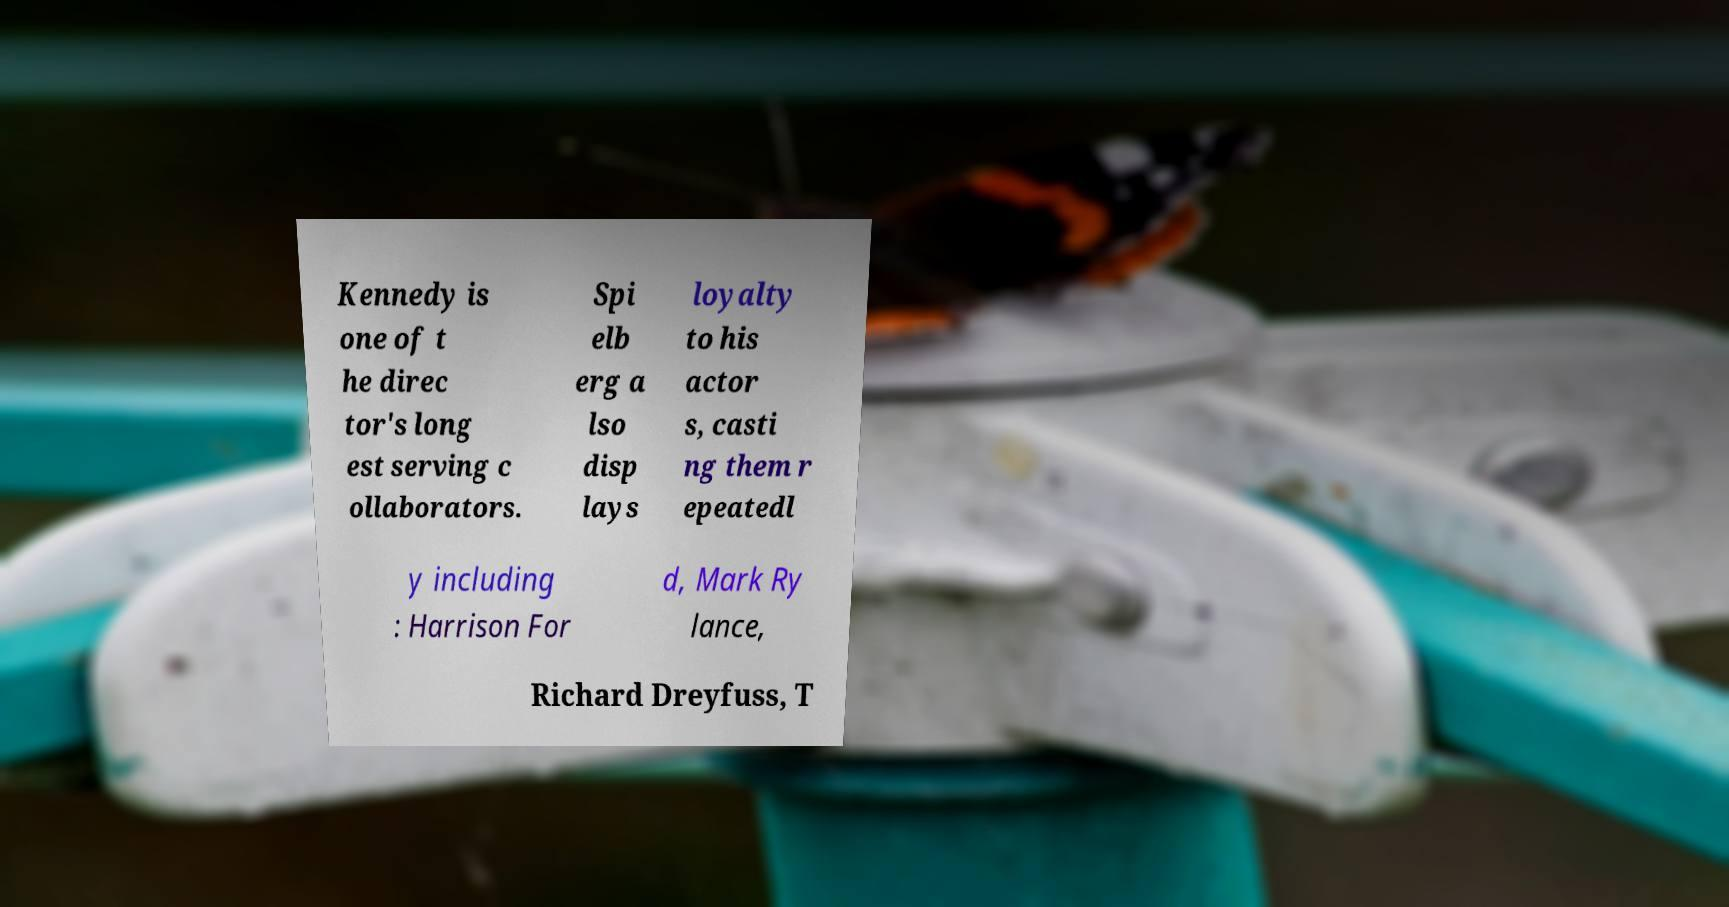Could you assist in decoding the text presented in this image and type it out clearly? Kennedy is one of t he direc tor's long est serving c ollaborators. Spi elb erg a lso disp lays loyalty to his actor s, casti ng them r epeatedl y including : Harrison For d, Mark Ry lance, Richard Dreyfuss, T 